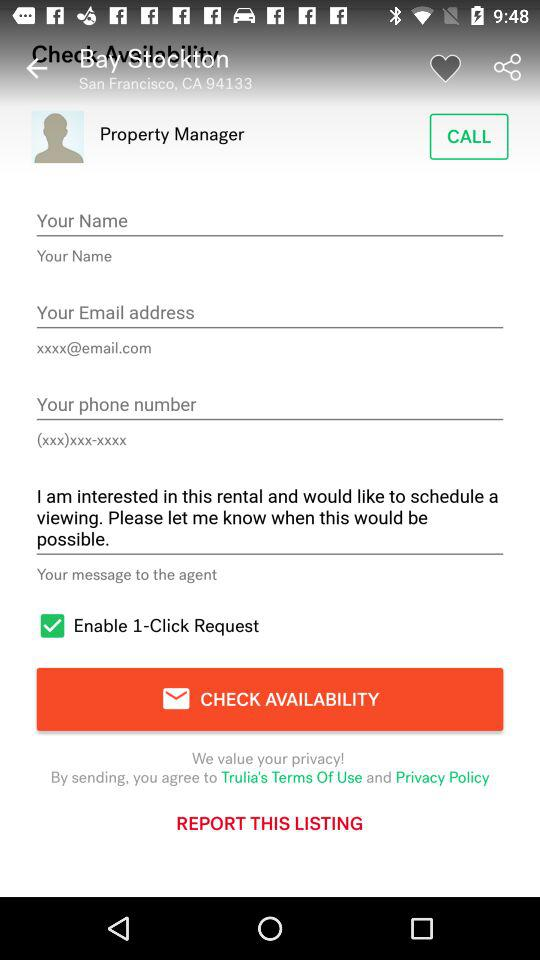What is the status of the "Enable 1-Click Request"? The status is "on". 